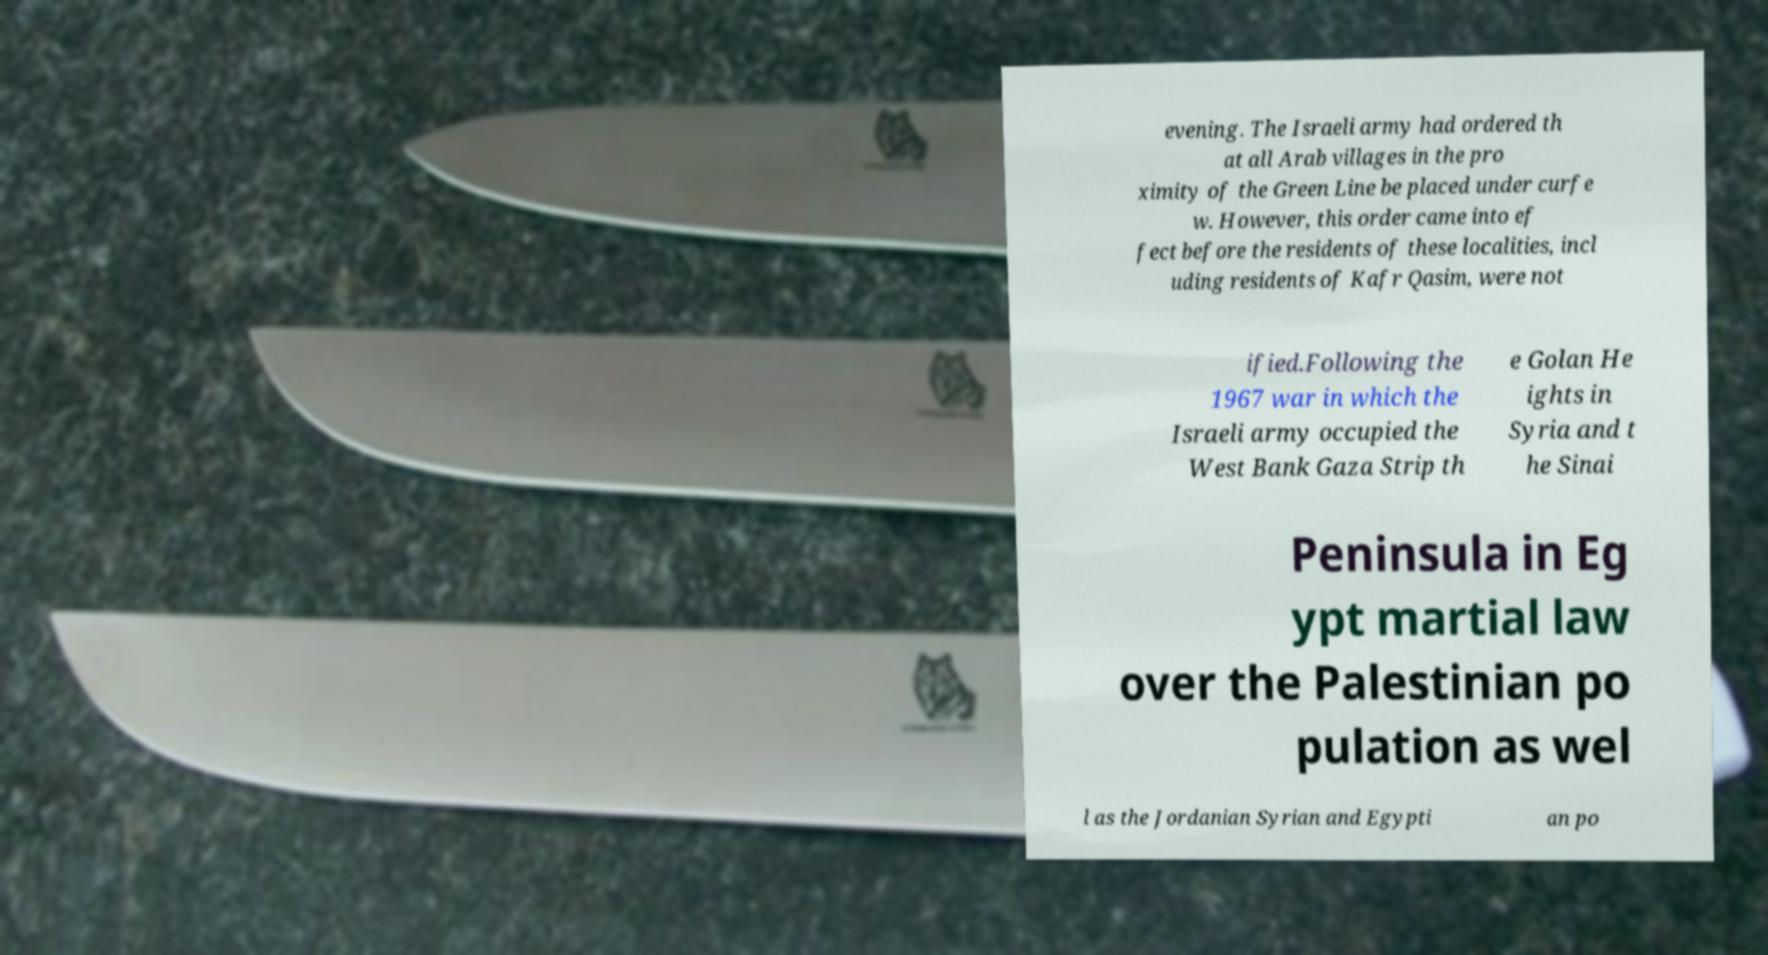There's text embedded in this image that I need extracted. Can you transcribe it verbatim? evening. The Israeli army had ordered th at all Arab villages in the pro ximity of the Green Line be placed under curfe w. However, this order came into ef fect before the residents of these localities, incl uding residents of Kafr Qasim, were not ified.Following the 1967 war in which the Israeli army occupied the West Bank Gaza Strip th e Golan He ights in Syria and t he Sinai Peninsula in Eg ypt martial law over the Palestinian po pulation as wel l as the Jordanian Syrian and Egypti an po 